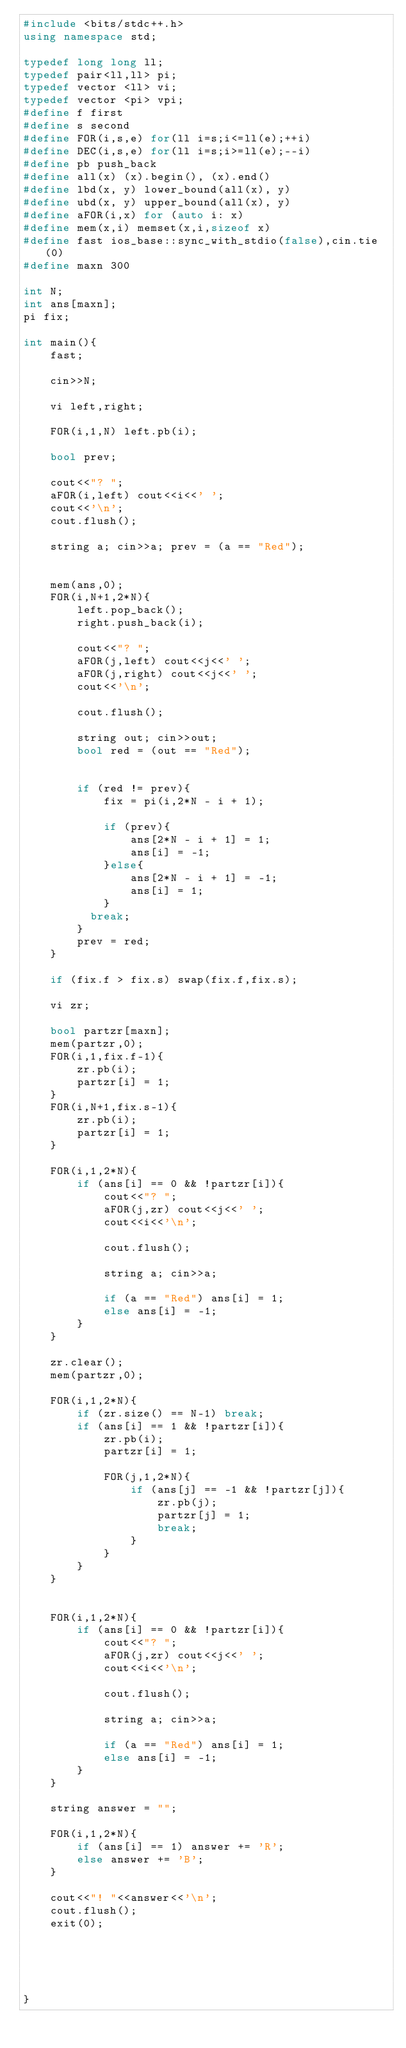<code> <loc_0><loc_0><loc_500><loc_500><_C++_>#include <bits/stdc++.h>
using namespace std;

typedef long long ll;
typedef pair<ll,ll> pi;
typedef vector <ll> vi;
typedef vector <pi> vpi;
#define f first
#define s second
#define FOR(i,s,e) for(ll i=s;i<=ll(e);++i)
#define DEC(i,s,e) for(ll i=s;i>=ll(e);--i)
#define pb push_back
#define all(x) (x).begin(), (x).end()
#define lbd(x, y) lower_bound(all(x), y)
#define ubd(x, y) upper_bound(all(x), y)
#define aFOR(i,x) for (auto i: x)
#define mem(x,i) memset(x,i,sizeof x)
#define fast ios_base::sync_with_stdio(false),cin.tie(0)
#define maxn 300

int N;
int ans[maxn];
pi fix;

int main(){
	fast;
	
	cin>>N;
	
	vi left,right;
	
	FOR(i,1,N) left.pb(i);
	
	bool prev;
	
	cout<<"? ";
	aFOR(i,left) cout<<i<<' ';
	cout<<'\n';
	cout.flush();
	
	string a; cin>>a; prev = (a == "Red");
	
		
	mem(ans,0);
	FOR(i,N+1,2*N){
		left.pop_back();
		right.push_back(i);
		
		cout<<"? ";
		aFOR(j,left) cout<<j<<' ';
		aFOR(j,right) cout<<j<<' ';
		cout<<'\n';
		
		cout.flush();
		
		string out; cin>>out;
		bool red = (out == "Red");

		
		if (red != prev){
			fix = pi(i,2*N - i + 1);
			
			if (prev){
				ans[2*N - i + 1] = 1;
				ans[i] = -1;
			}else{
				ans[2*N - i + 1] = -1;
				ans[i] = 1;
			}
          break;
		}
		prev = red;
	}
	
	if (fix.f > fix.s) swap(fix.f,fix.s);
	
	vi zr;
	
	bool partzr[maxn];
	mem(partzr,0);
	FOR(i,1,fix.f-1){
		zr.pb(i);
		partzr[i] = 1;
	}
	FOR(i,N+1,fix.s-1){
		zr.pb(i);
		partzr[i] = 1;
	}
	
	FOR(i,1,2*N){
		if (ans[i] == 0 && !partzr[i]){
			cout<<"? ";
			aFOR(j,zr) cout<<j<<' ';
			cout<<i<<'\n';
			
			cout.flush();
			
			string a; cin>>a;
			
			if (a == "Red") ans[i] = 1;
			else ans[i] = -1;
		}
	}

	zr.clear();
	mem(partzr,0);

	FOR(i,1,2*N){
		if (zr.size() == N-1) break;
		if (ans[i] == 1 && !partzr[i]){
			zr.pb(i);
			partzr[i] = 1;
			
			FOR(j,1,2*N){
				if (ans[j] == -1 && !partzr[j]){
					zr.pb(j);
					partzr[j] = 1;
					break;
				}
			}
		}
	}
					

	FOR(i,1,2*N){
		if (ans[i] == 0 && !partzr[i]){
			cout<<"? ";
			aFOR(j,zr) cout<<j<<' ';
			cout<<i<<'\n';
			
			cout.flush();
			
			string a; cin>>a;
			
			if (a == "Red") ans[i] = 1;
			else ans[i] = -1;
		}
	}		
	
	string answer = "";
	
	FOR(i,1,2*N){
		if (ans[i] == 1) answer += 'R';
		else answer += 'B';
	}
	
	cout<<"! "<<answer<<'\n';
	cout.flush();
	exit(0);
				
	
	
	
	
}

</code> 